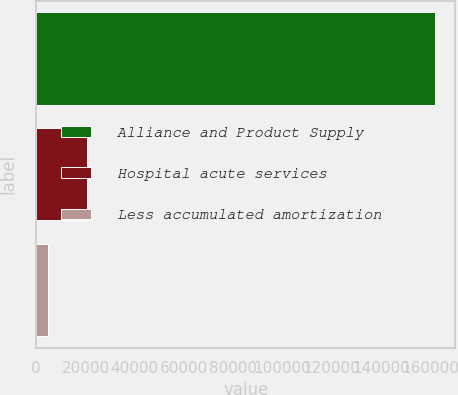Convert chart. <chart><loc_0><loc_0><loc_500><loc_500><bar_chart><fcel>Alliance and Product Supply<fcel>Hospital acute services<fcel>Less accumulated amortization<nl><fcel>162100<fcel>20580.4<fcel>4856<nl></chart> 